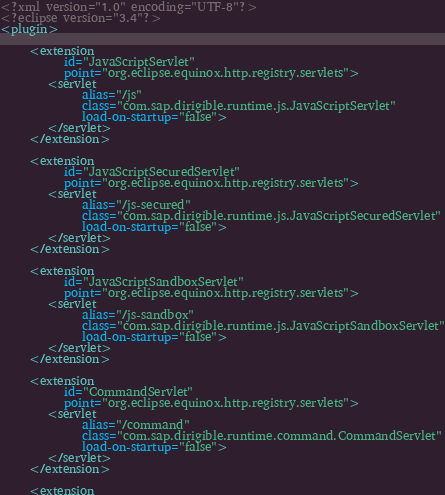Convert code to text. <code><loc_0><loc_0><loc_500><loc_500><_XML_><?xml version="1.0" encoding="UTF-8"?>
<?eclipse version="3.4"?>
<plugin>

     <extension
           id="JavaScriptServlet"
           point="org.eclipse.equinox.http.registry.servlets">
        <servlet
              alias="/js"
              class="com.sap.dirigible.runtime.js.JavaScriptServlet"
              load-on-startup="false">
        </servlet>
     </extension>
	 
	 <extension
           id="JavaScriptSecuredServlet"
           point="org.eclipse.equinox.http.registry.servlets">
        <servlet
              alias="/js-secured"
              class="com.sap.dirigible.runtime.js.JavaScriptSecuredServlet"
              load-on-startup="false">
        </servlet>
     </extension>
	 
	 <extension
           id="JavaScriptSandboxServlet"
           point="org.eclipse.equinox.http.registry.servlets">
        <servlet
              alias="/js-sandbox"
              class="com.sap.dirigible.runtime.js.JavaScriptSandboxServlet"
              load-on-startup="false">
        </servlet>
     </extension>
	 
	 <extension
           id="CommandServlet"
           point="org.eclipse.equinox.http.registry.servlets">
        <servlet
              alias="/command"
              class="com.sap.dirigible.runtime.command.CommandServlet"
              load-on-startup="false">
        </servlet>
     </extension>
	 
	 <extension</code> 